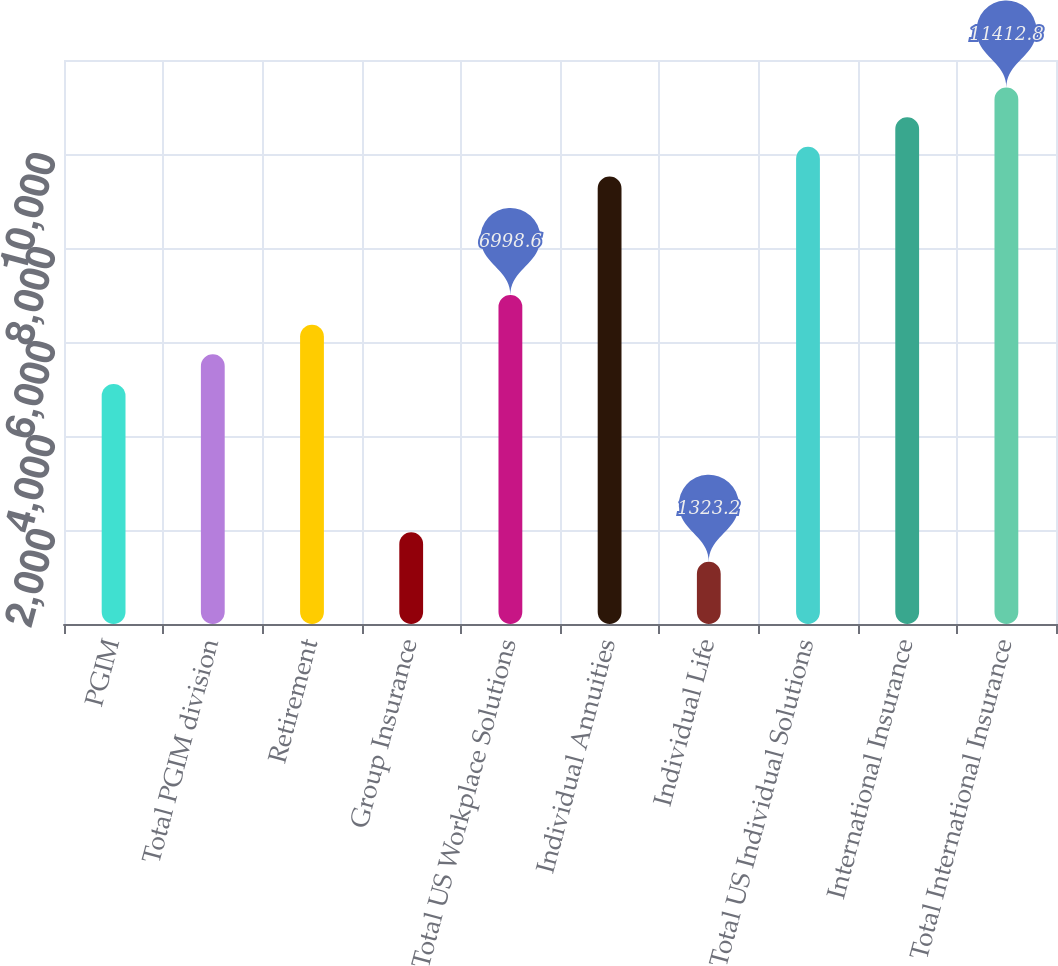Convert chart to OTSL. <chart><loc_0><loc_0><loc_500><loc_500><bar_chart><fcel>PGIM<fcel>Total PGIM division<fcel>Retirement<fcel>Group Insurance<fcel>Total US Workplace Solutions<fcel>Individual Annuities<fcel>Individual Life<fcel>Total US Individual Solutions<fcel>International Insurance<fcel>Total International Insurance<nl><fcel>5106.8<fcel>5737.4<fcel>6368<fcel>1953.8<fcel>6998.6<fcel>9521<fcel>1323.2<fcel>10151.6<fcel>10782.2<fcel>11412.8<nl></chart> 